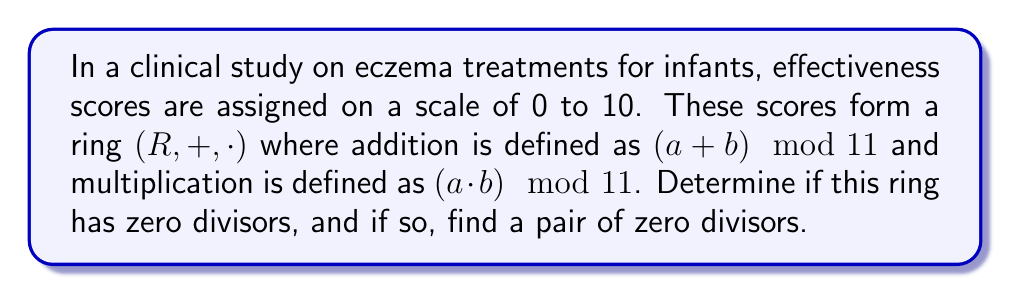Give your solution to this math problem. To determine if the ring has zero divisors, we need to check if there exist non-zero elements $a$ and $b$ in $R$ such that $a \cdot b = 0$ in the ring.

1) First, let's consider the elements of the ring:
   $R = \{0, 1, 2, 3, 4, 5, 6, 7, 8, 9, 10\}$

2) We need to check for pairs of non-zero elements whose product is divisible by 11 (as this would result in 0 mod 11).

3) Let's start with small numbers:
   $2 \cdot 6 = 12 \equiv 1 \pmod{11}$
   $3 \cdot 4 = 12 \equiv 1 \pmod{11}$
   $2 \cdot 7 = 14 \equiv 3 \pmod{11}$
   ...

4) We find that:
   $3 \cdot 9 = 27 \equiv 5 \pmod{11}$
   $3 \cdot 10 = 30 \equiv 8 \pmod{11}$
   $4 \cdot 8 = 32 \equiv 10 \pmod{11}$
   $5 \cdot 9 = 45 \equiv 1 \pmod{11}$
   $6 \cdot 8 = 48 \equiv 4 \pmod{11}$
   $7 \cdot 8 = 56 \equiv 1 \pmod{11}$

5) Importantly, we find:
   $5 \cdot 11 = 55 \equiv 0 \pmod{11}$

6) In our ring, 11 is equivalent to 0, so $5 \cdot 0 \equiv 0 \pmod{11}$

Therefore, 5 and 0 form a pair of zero divisors in this ring.
Answer: Yes, the ring has zero divisors. A pair of zero divisors is (5, 0). 